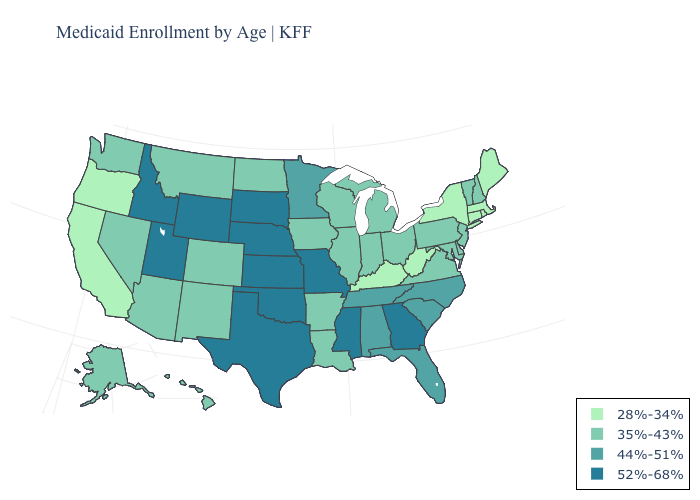Is the legend a continuous bar?
Quick response, please. No. How many symbols are there in the legend?
Concise answer only. 4. Which states have the lowest value in the Northeast?
Keep it brief. Connecticut, Maine, Massachusetts, New York, Rhode Island. Does Indiana have a higher value than Nevada?
Give a very brief answer. No. Does Minnesota have a lower value than Texas?
Give a very brief answer. Yes. Among the states that border Wyoming , which have the lowest value?
Answer briefly. Colorado, Montana. Name the states that have a value in the range 35%-43%?
Be succinct. Alaska, Arizona, Arkansas, Colorado, Delaware, Hawaii, Illinois, Indiana, Iowa, Louisiana, Maryland, Michigan, Montana, Nevada, New Hampshire, New Jersey, New Mexico, North Dakota, Ohio, Pennsylvania, Vermont, Virginia, Washington, Wisconsin. Does the first symbol in the legend represent the smallest category?
Concise answer only. Yes. Is the legend a continuous bar?
Quick response, please. No. What is the highest value in states that border North Dakota?
Short answer required. 52%-68%. Name the states that have a value in the range 44%-51%?
Give a very brief answer. Alabama, Florida, Minnesota, North Carolina, South Carolina, Tennessee. Name the states that have a value in the range 44%-51%?
Be succinct. Alabama, Florida, Minnesota, North Carolina, South Carolina, Tennessee. Name the states that have a value in the range 35%-43%?
Short answer required. Alaska, Arizona, Arkansas, Colorado, Delaware, Hawaii, Illinois, Indiana, Iowa, Louisiana, Maryland, Michigan, Montana, Nevada, New Hampshire, New Jersey, New Mexico, North Dakota, Ohio, Pennsylvania, Vermont, Virginia, Washington, Wisconsin. Among the states that border Mississippi , does Louisiana have the highest value?
Be succinct. No. Among the states that border South Dakota , which have the lowest value?
Answer briefly. Iowa, Montana, North Dakota. 